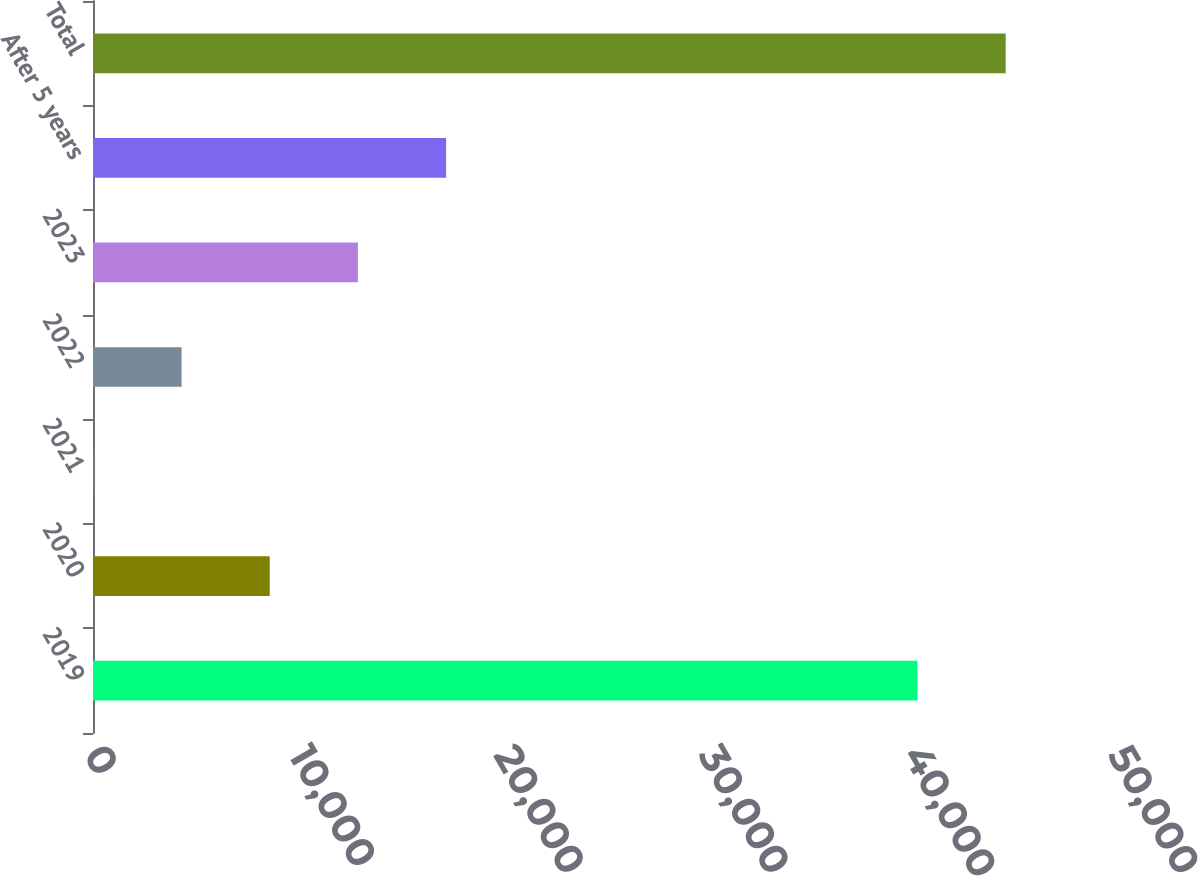Convert chart. <chart><loc_0><loc_0><loc_500><loc_500><bar_chart><fcel>2019<fcel>2020<fcel>2021<fcel>2022<fcel>2023<fcel>After 5 years<fcel>Total<nl><fcel>40259<fcel>8630.2<fcel>19<fcel>4324.6<fcel>12935.8<fcel>17241.4<fcel>44564.6<nl></chart> 